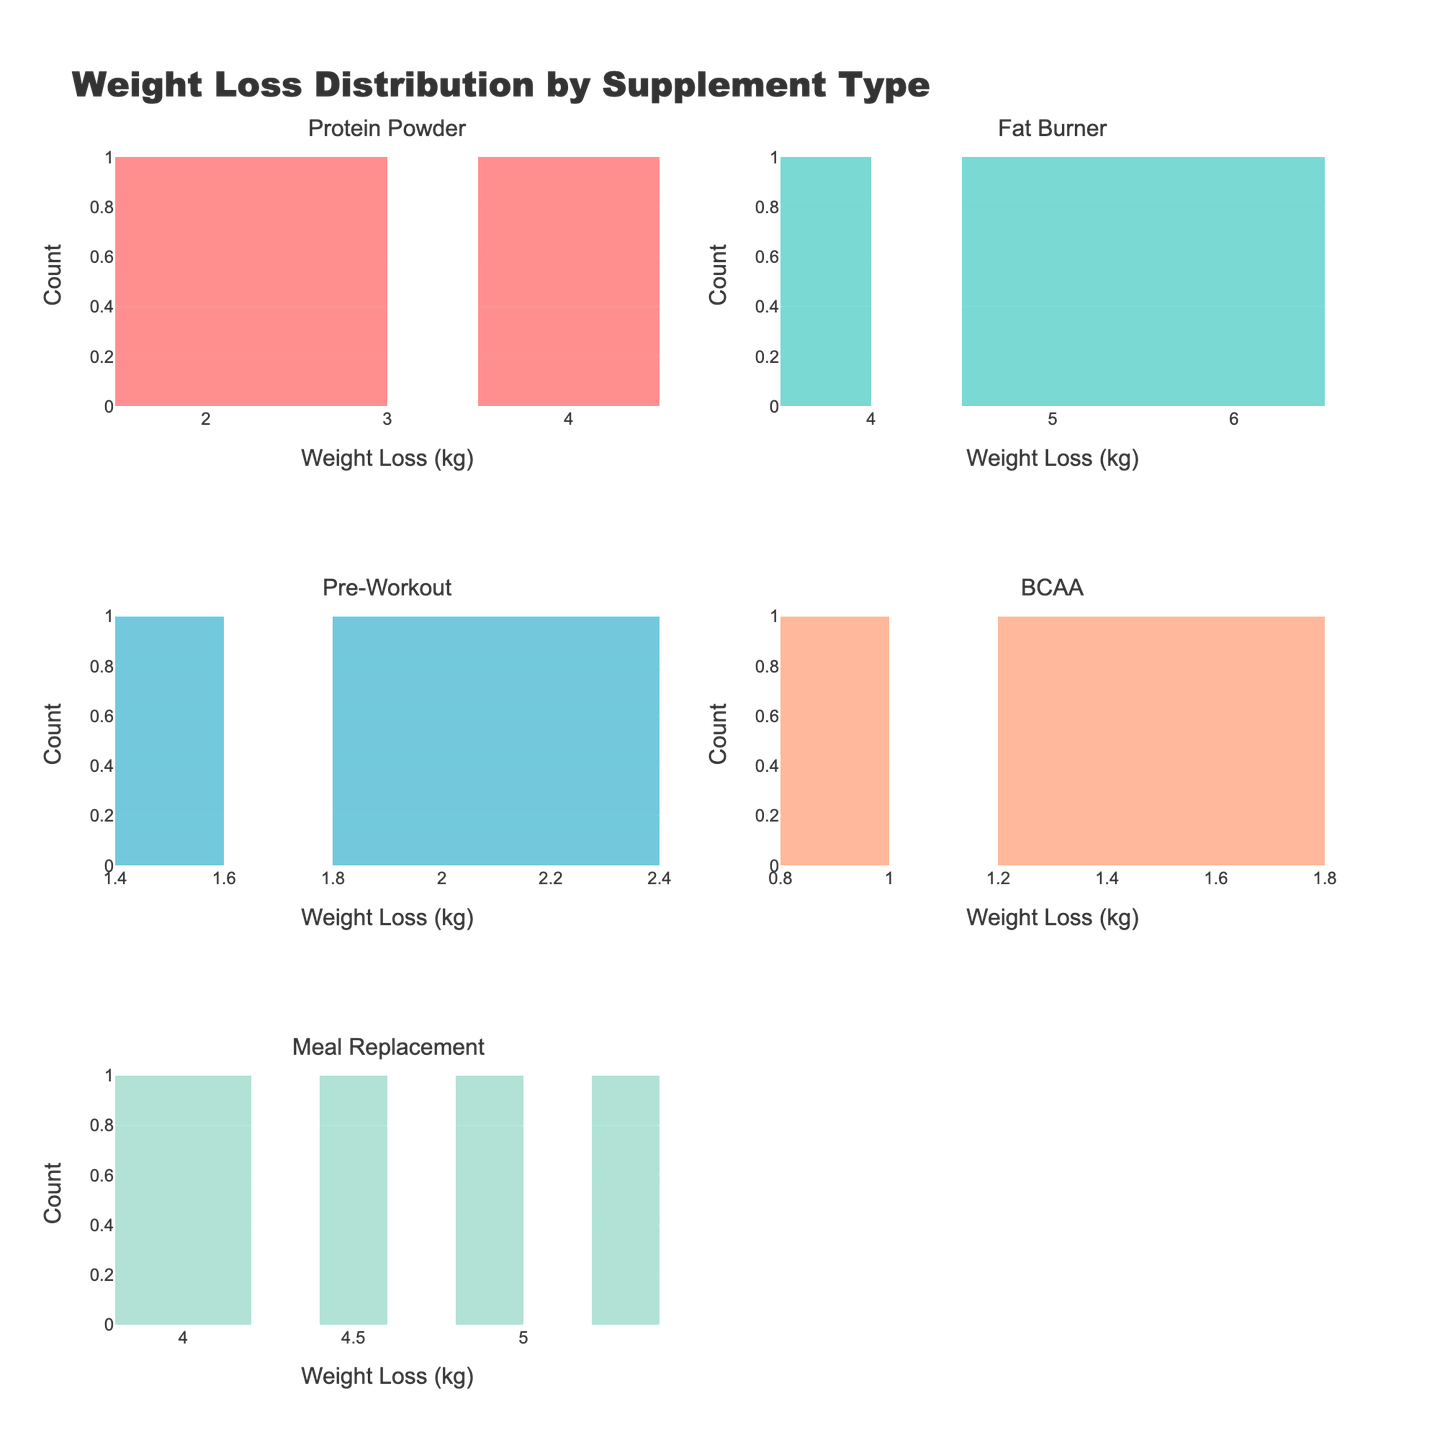What is the title of the figure? The title is prominently displayed at the top of the figure. It reads "Weight Loss Distribution by Supplement Type," indicating the subject matter of the histograms.
Answer: Weight Loss Distribution by Supplement Type How many subplots are shown in the figure? There are six unique product types, and each one has a dedicated histogram subplot. The figure is designed to have 3 rows and 2 columns of subplots.
Answer: 6 What does the x-axis represent in each subplot? Each x-axis is labeled "Weight Loss (kg)," signifying that the horizontal axis quantifies the weight loss in kilograms across different supplement types.
Answer: Weight Loss (kg) Which supplement type shows the highest recorded weight loss? By visually inspecting the maximum values on the x-axes of all subplots, the Fat Burner histogram shows a weight loss reaching up to 6.1 kg, which is higher than the maximum values in other subplots.
Answer: Fat Burner What color is used for the Fat Burner histogram? The Fat Burner histogram is colored using the second custom color from the predefined sequence, which visually appears as a teal or turquoise shade.
Answer: Teal (turquoise) Which supplement type has the smallest range of weight loss values? By comparing the spread of data on the x-axes of all subplots, the BCAA histogram has the values concentrated between 0.9 kg and 2.0 kg, indicating the smallest range.
Answer: BCAA What is the average weight loss for the Protein Powder group? The values for Protein Powder are 2.1, 3.5, 1.8, 4.2, and 2.7 kg. Summing these values gives 14.3 kg, and dividing by 5 (number of samples) results in an average of 2.86 kg.
Answer: 2.86 kg Which supplement type has the most evenly distributed weight loss results? By inspecting the shape of the histograms, the Meal Replacement histogram appears the most uniform, indicating an even distribution of weight loss values.
Answer: Meal Replacement Which supplement type has the highest count in any single bin? By examining the heights of the bars in all histograms, the Fat Burner histogram has a bin with the highest count, which appears to be 2 or more.
Answer: Fat Burner How do the weight loss results for Pre-Workout compare to those for BCAA? The weight loss values for Pre-Workout range from 1.5 kg to 2.8 kg, while BCAA values range from 0.9 kg to 2.0 kg. Pre-Workout results trend higher than BCAA but both are on the lower side compared to other supplements.
Answer: Pre-Workout values are higher 